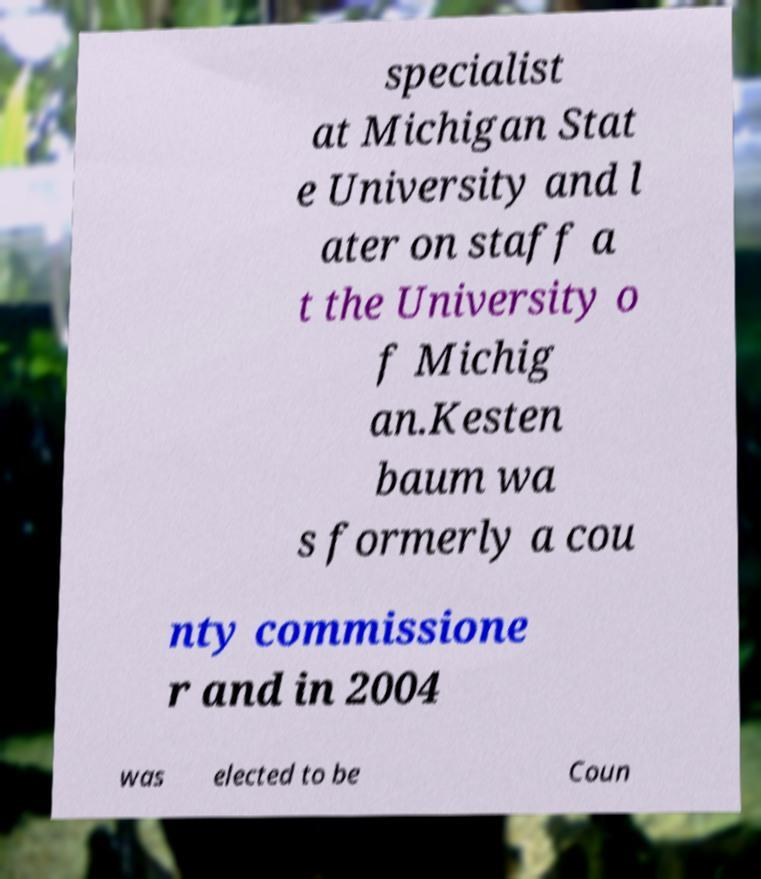Please read and relay the text visible in this image. What does it say? specialist at Michigan Stat e University and l ater on staff a t the University o f Michig an.Kesten baum wa s formerly a cou nty commissione r and in 2004 was elected to be Coun 